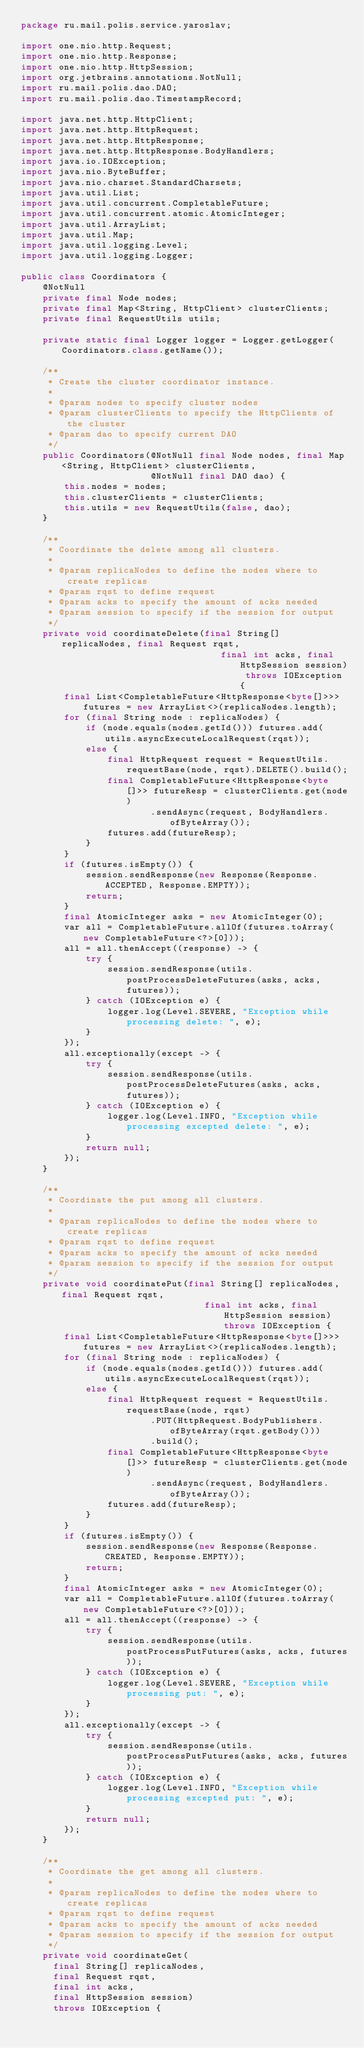<code> <loc_0><loc_0><loc_500><loc_500><_Java_>package ru.mail.polis.service.yaroslav;

import one.nio.http.Request;
import one.nio.http.Response;
import one.nio.http.HttpSession;
import org.jetbrains.annotations.NotNull;
import ru.mail.polis.dao.DAO;
import ru.mail.polis.dao.TimestampRecord;

import java.net.http.HttpClient;
import java.net.http.HttpRequest;
import java.net.http.HttpResponse;
import java.net.http.HttpResponse.BodyHandlers;
import java.io.IOException;
import java.nio.ByteBuffer;
import java.nio.charset.StandardCharsets;
import java.util.List;
import java.util.concurrent.CompletableFuture;
import java.util.concurrent.atomic.AtomicInteger;
import java.util.ArrayList;
import java.util.Map;
import java.util.logging.Level;
import java.util.logging.Logger;

public class Coordinators {
    @NotNull
    private final Node nodes;
    private final Map<String, HttpClient> clusterClients;
    private final RequestUtils utils;

    private static final Logger logger = Logger.getLogger(Coordinators.class.getName());

    /**
     * Create the cluster coordinator instance.
     *
     * @param nodes to specify cluster nodes
     * @param clusterClients to specify the HttpClients of the cluster
     * @param dao to specify current DAO
     */
    public Coordinators(@NotNull final Node nodes, final Map<String, HttpClient> clusterClients,
                        @NotNull final DAO dao) {
        this.nodes = nodes;
        this.clusterClients = clusterClients;
        this.utils = new RequestUtils(false, dao);
    }

    /**
     * Coordinate the delete among all clusters.
     *
     * @param replicaNodes to define the nodes where to create replicas
     * @param rqst to define request
     * @param acks to specify the amount of acks needed
     * @param session to specify if the session for output
     */
    private void coordinateDelete(final String[] replicaNodes, final Request rqst,
                                     final int acks, final HttpSession session) throws IOException {
        final List<CompletableFuture<HttpResponse<byte[]>>> futures = new ArrayList<>(replicaNodes.length);
        for (final String node : replicaNodes) {
            if (node.equals(nodes.getId())) futures.add(utils.asyncExecuteLocalRequest(rqst));
            else {
                final HttpRequest request = RequestUtils.requestBase(node, rqst).DELETE().build();
                final CompletableFuture<HttpResponse<byte[]>> futureResp = clusterClients.get(node)
                        .sendAsync(request, BodyHandlers.ofByteArray());
                futures.add(futureResp);
            }
        }
        if (futures.isEmpty()) {
            session.sendResponse(new Response(Response.ACCEPTED, Response.EMPTY));
            return;
        }
        final AtomicInteger asks = new AtomicInteger(0);
        var all = CompletableFuture.allOf(futures.toArray(new CompletableFuture<?>[0]));
        all = all.thenAccept((response) -> {
            try {
                session.sendResponse(utils.postProcessDeleteFutures(asks, acks, futures));
            } catch (IOException e) {
                logger.log(Level.SEVERE, "Exception while processing delete: ", e);
            }
        });
        all.exceptionally(except -> {
            try {
                session.sendResponse(utils.postProcessDeleteFutures(asks, acks, futures));
            } catch (IOException e) {
                logger.log(Level.INFO, "Exception while processing excepted delete: ", e);
            }
            return null;
        });
    }

    /**
     * Coordinate the put among all clusters.
     *
     * @param replicaNodes to define the nodes where to create replicas
     * @param rqst to define request
     * @param acks to specify the amount of acks needed
     * @param session to specify if the session for output
     */
    private void coordinatePut(final String[] replicaNodes, final Request rqst,
                                  final int acks, final HttpSession session) throws IOException {
        final List<CompletableFuture<HttpResponse<byte[]>>> futures = new ArrayList<>(replicaNodes.length);
        for (final String node : replicaNodes) {
            if (node.equals(nodes.getId())) futures.add(utils.asyncExecuteLocalRequest(rqst));
            else {
                final HttpRequest request = RequestUtils.requestBase(node, rqst)
                        .PUT(HttpRequest.BodyPublishers.ofByteArray(rqst.getBody()))
                        .build();
                final CompletableFuture<HttpResponse<byte[]>> futureResp = clusterClients.get(node)
                        .sendAsync(request, BodyHandlers.ofByteArray());
                futures.add(futureResp);
            }
        }
        if (futures.isEmpty()) {
            session.sendResponse(new Response(Response.CREATED, Response.EMPTY));
            return;
        }
        final AtomicInteger asks = new AtomicInteger(0);
        var all = CompletableFuture.allOf(futures.toArray(new CompletableFuture<?>[0]));
        all = all.thenAccept((response) -> {
            try {
                session.sendResponse(utils.postProcessPutFutures(asks, acks, futures));
            } catch (IOException e) {
                logger.log(Level.SEVERE, "Exception while processing put: ", e);
            }
        });
        all.exceptionally(except -> {
            try {
                session.sendResponse(utils.postProcessPutFutures(asks, acks, futures));
            } catch (IOException e) {
                logger.log(Level.INFO, "Exception while processing excepted put: ", e);
            }
            return null;
        });
    }

    /**
     * Coordinate the get among all clusters.
     *
     * @param replicaNodes to define the nodes where to create replicas
     * @param rqst to define request
     * @param acks to specify the amount of acks needed
     * @param session to specify if the session for output
     */
    private void coordinateGet(
      final String[] replicaNodes, 
      final Request rqst,
      final int acks, 
      final HttpSession session) 
      throws IOException {</code> 